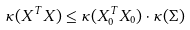Convert formula to latex. <formula><loc_0><loc_0><loc_500><loc_500>\kappa ( X ^ { T } X ) & \leq \kappa ( X _ { 0 } ^ { T } X _ { 0 } ) \cdot \kappa ( \Sigma )</formula> 